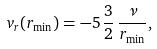Convert formula to latex. <formula><loc_0><loc_0><loc_500><loc_500>v _ { r } ( r _ { \min } ) = - 5 \, \frac { 3 } { 2 } \, \frac { \nu } { r _ { \min } } ,</formula> 